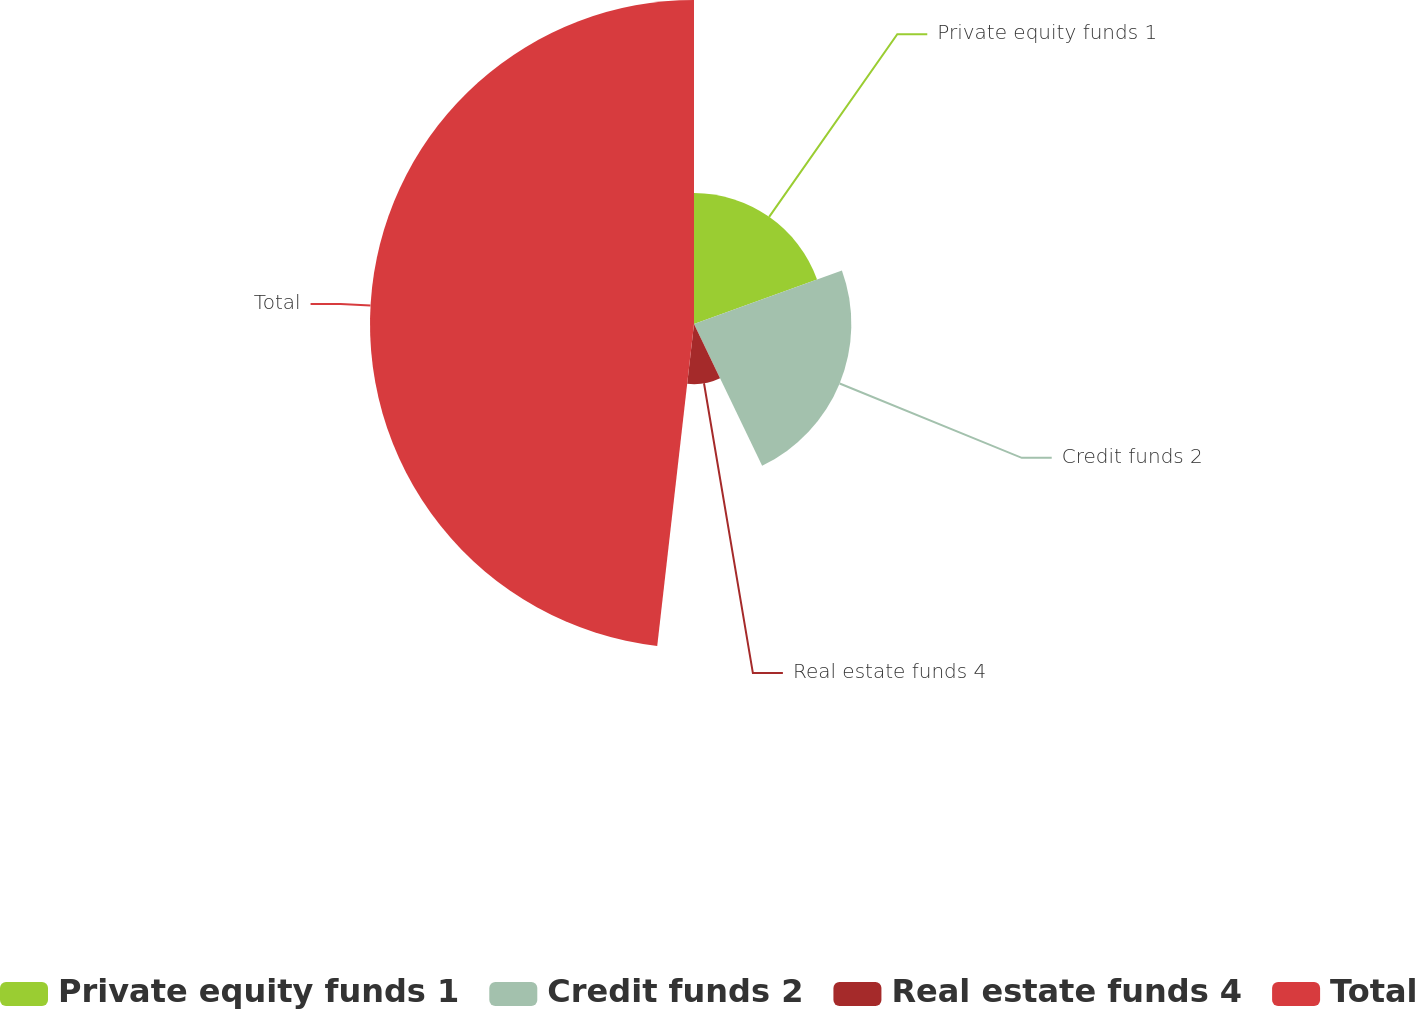Convert chart to OTSL. <chart><loc_0><loc_0><loc_500><loc_500><pie_chart><fcel>Private equity funds 1<fcel>Credit funds 2<fcel>Real estate funds 4<fcel>Total<nl><fcel>19.47%<fcel>23.4%<fcel>8.94%<fcel>48.19%<nl></chart> 